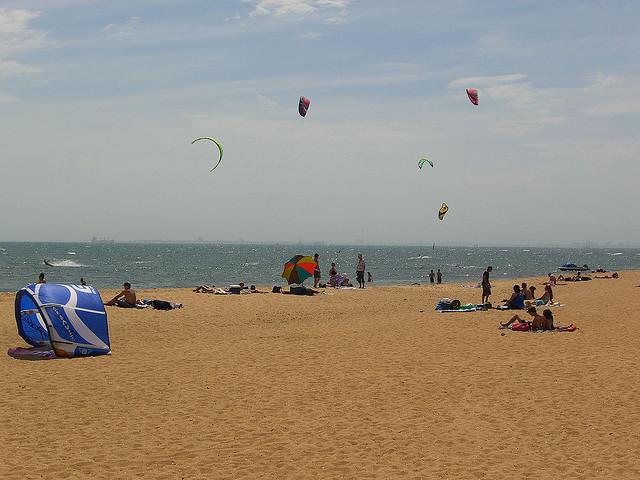What color kite is on the ground?
Quick response, please. Blue. Are there sunbathers on the beach, too?
Give a very brief answer. Yes. Is there a boat?
Give a very brief answer. Yes. Is a strong breeze needed for this activity?
Be succinct. Yes. How many umbrellas are visible?
Keep it brief. 1. How many kites are flying?
Be succinct. 5. Hazy or sunny?
Give a very brief answer. Sunny. What color is the ocean?
Concise answer only. Blue. How many chairs are visible?
Give a very brief answer. 0. 